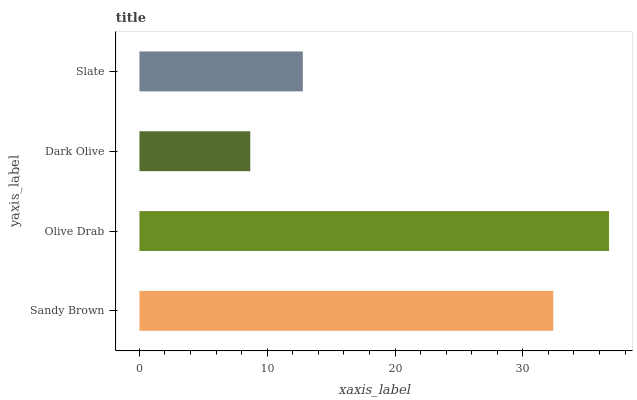Is Dark Olive the minimum?
Answer yes or no. Yes. Is Olive Drab the maximum?
Answer yes or no. Yes. Is Olive Drab the minimum?
Answer yes or no. No. Is Dark Olive the maximum?
Answer yes or no. No. Is Olive Drab greater than Dark Olive?
Answer yes or no. Yes. Is Dark Olive less than Olive Drab?
Answer yes or no. Yes. Is Dark Olive greater than Olive Drab?
Answer yes or no. No. Is Olive Drab less than Dark Olive?
Answer yes or no. No. Is Sandy Brown the high median?
Answer yes or no. Yes. Is Slate the low median?
Answer yes or no. Yes. Is Slate the high median?
Answer yes or no. No. Is Olive Drab the low median?
Answer yes or no. No. 